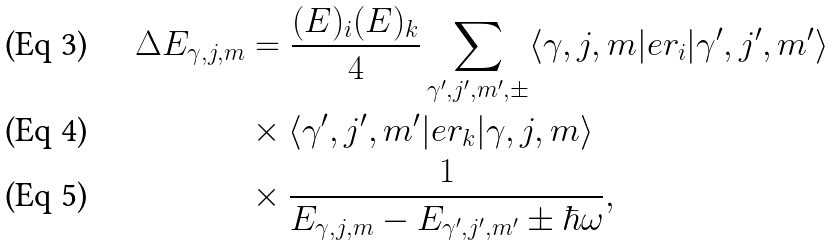Convert formula to latex. <formula><loc_0><loc_0><loc_500><loc_500>\Delta E _ { \gamma , j , m } & = \frac { ( E ) _ { i } ( E ) _ { k } } { 4 } \sum _ { \gamma ^ { \prime } , j ^ { \prime } , m ^ { \prime } , \pm } \langle \gamma , j , m | e r _ { i } | \gamma ^ { \prime } , j ^ { \prime } , m ^ { \prime } \rangle \\ & \times \langle \gamma ^ { \prime } , j ^ { \prime } , m ^ { \prime } | e r _ { k } | \gamma , j , m \rangle \\ & \times \frac { 1 } { E _ { \gamma , j , m } - E _ { \gamma ^ { \prime } , j ^ { \prime } , m ^ { \prime } } \pm \hbar { \omega } } ,</formula> 